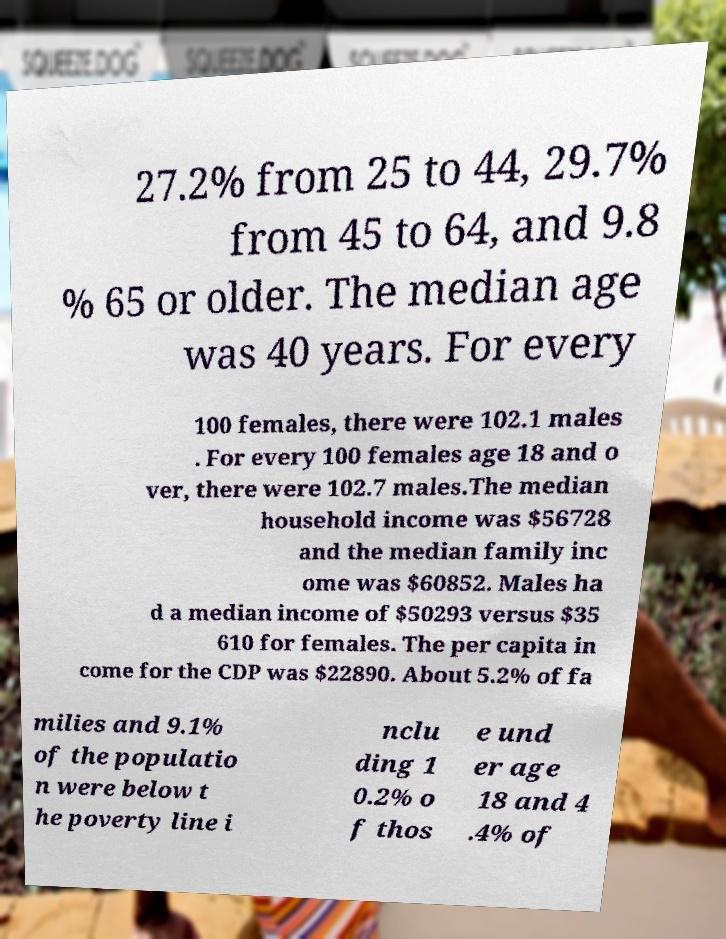Please identify and transcribe the text found in this image. 27.2% from 25 to 44, 29.7% from 45 to 64, and 9.8 % 65 or older. The median age was 40 years. For every 100 females, there were 102.1 males . For every 100 females age 18 and o ver, there were 102.7 males.The median household income was $56728 and the median family inc ome was $60852. Males ha d a median income of $50293 versus $35 610 for females. The per capita in come for the CDP was $22890. About 5.2% of fa milies and 9.1% of the populatio n were below t he poverty line i nclu ding 1 0.2% o f thos e und er age 18 and 4 .4% of 